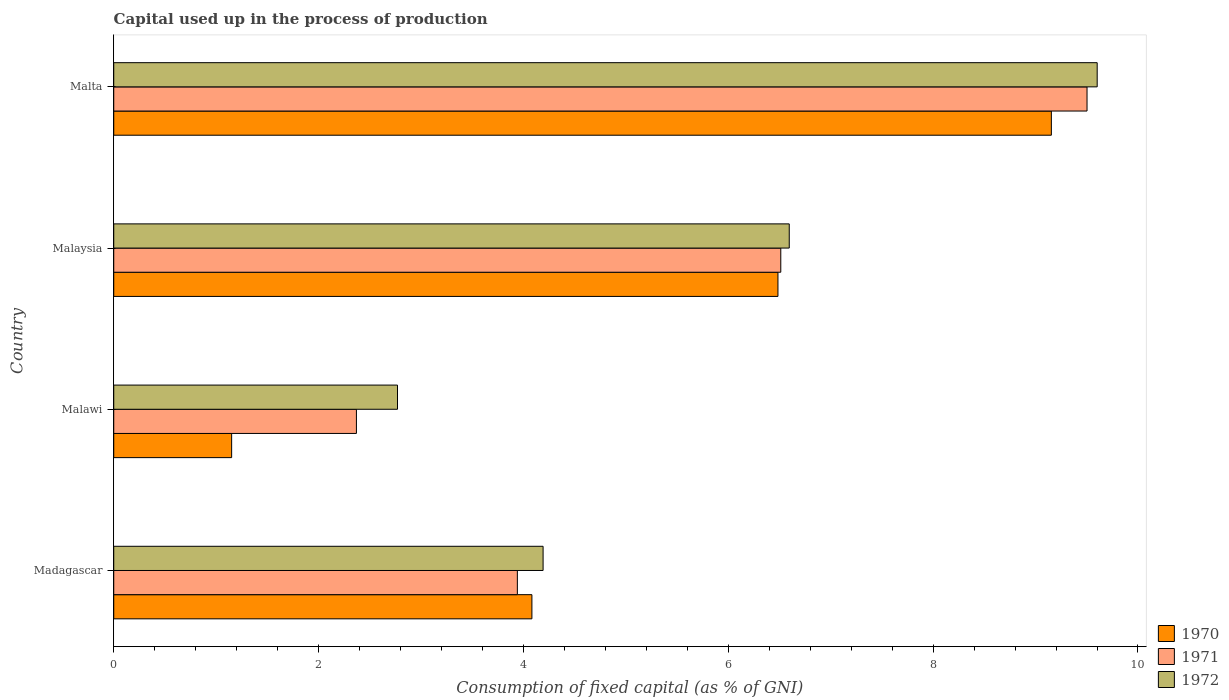How many groups of bars are there?
Give a very brief answer. 4. Are the number of bars per tick equal to the number of legend labels?
Keep it short and to the point. Yes. How many bars are there on the 1st tick from the bottom?
Your response must be concise. 3. What is the label of the 3rd group of bars from the top?
Your answer should be compact. Malawi. In how many cases, is the number of bars for a given country not equal to the number of legend labels?
Offer a very short reply. 0. What is the capital used up in the process of production in 1970 in Malaysia?
Your answer should be compact. 6.48. Across all countries, what is the maximum capital used up in the process of production in 1970?
Give a very brief answer. 9.15. Across all countries, what is the minimum capital used up in the process of production in 1972?
Offer a very short reply. 2.77. In which country was the capital used up in the process of production in 1971 maximum?
Make the answer very short. Malta. In which country was the capital used up in the process of production in 1970 minimum?
Offer a very short reply. Malawi. What is the total capital used up in the process of production in 1970 in the graph?
Your answer should be very brief. 20.87. What is the difference between the capital used up in the process of production in 1970 in Madagascar and that in Malaysia?
Ensure brevity in your answer.  -2.4. What is the difference between the capital used up in the process of production in 1972 in Malawi and the capital used up in the process of production in 1970 in Malta?
Offer a terse response. -6.38. What is the average capital used up in the process of production in 1971 per country?
Provide a succinct answer. 5.58. What is the difference between the capital used up in the process of production in 1971 and capital used up in the process of production in 1970 in Malaysia?
Provide a succinct answer. 0.03. In how many countries, is the capital used up in the process of production in 1970 greater than 2 %?
Keep it short and to the point. 3. What is the ratio of the capital used up in the process of production in 1971 in Malawi to that in Malta?
Give a very brief answer. 0.25. Is the difference between the capital used up in the process of production in 1971 in Madagascar and Malawi greater than the difference between the capital used up in the process of production in 1970 in Madagascar and Malawi?
Give a very brief answer. No. What is the difference between the highest and the second highest capital used up in the process of production in 1972?
Your answer should be very brief. 3.01. What is the difference between the highest and the lowest capital used up in the process of production in 1970?
Provide a succinct answer. 8. In how many countries, is the capital used up in the process of production in 1972 greater than the average capital used up in the process of production in 1972 taken over all countries?
Offer a terse response. 2. What does the 3rd bar from the bottom in Malaysia represents?
Offer a terse response. 1972. Is it the case that in every country, the sum of the capital used up in the process of production in 1971 and capital used up in the process of production in 1970 is greater than the capital used up in the process of production in 1972?
Provide a succinct answer. Yes. How many bars are there?
Offer a very short reply. 12. What is the difference between two consecutive major ticks on the X-axis?
Offer a very short reply. 2. Does the graph contain any zero values?
Offer a very short reply. No. Does the graph contain grids?
Ensure brevity in your answer.  No. What is the title of the graph?
Your response must be concise. Capital used up in the process of production. Does "1981" appear as one of the legend labels in the graph?
Make the answer very short. No. What is the label or title of the X-axis?
Your answer should be very brief. Consumption of fixed capital (as % of GNI). What is the label or title of the Y-axis?
Offer a very short reply. Country. What is the Consumption of fixed capital (as % of GNI) of 1970 in Madagascar?
Offer a very short reply. 4.08. What is the Consumption of fixed capital (as % of GNI) of 1971 in Madagascar?
Your answer should be compact. 3.94. What is the Consumption of fixed capital (as % of GNI) in 1972 in Madagascar?
Make the answer very short. 4.19. What is the Consumption of fixed capital (as % of GNI) of 1970 in Malawi?
Ensure brevity in your answer.  1.15. What is the Consumption of fixed capital (as % of GNI) of 1971 in Malawi?
Your answer should be very brief. 2.37. What is the Consumption of fixed capital (as % of GNI) in 1972 in Malawi?
Offer a very short reply. 2.77. What is the Consumption of fixed capital (as % of GNI) in 1970 in Malaysia?
Offer a very short reply. 6.48. What is the Consumption of fixed capital (as % of GNI) in 1971 in Malaysia?
Offer a very short reply. 6.51. What is the Consumption of fixed capital (as % of GNI) of 1972 in Malaysia?
Offer a terse response. 6.6. What is the Consumption of fixed capital (as % of GNI) of 1970 in Malta?
Provide a succinct answer. 9.15. What is the Consumption of fixed capital (as % of GNI) in 1971 in Malta?
Offer a very short reply. 9.5. What is the Consumption of fixed capital (as % of GNI) in 1972 in Malta?
Your answer should be compact. 9.6. Across all countries, what is the maximum Consumption of fixed capital (as % of GNI) in 1970?
Give a very brief answer. 9.15. Across all countries, what is the maximum Consumption of fixed capital (as % of GNI) of 1971?
Give a very brief answer. 9.5. Across all countries, what is the maximum Consumption of fixed capital (as % of GNI) in 1972?
Your response must be concise. 9.6. Across all countries, what is the minimum Consumption of fixed capital (as % of GNI) in 1970?
Provide a succinct answer. 1.15. Across all countries, what is the minimum Consumption of fixed capital (as % of GNI) of 1971?
Provide a short and direct response. 2.37. Across all countries, what is the minimum Consumption of fixed capital (as % of GNI) in 1972?
Your answer should be very brief. 2.77. What is the total Consumption of fixed capital (as % of GNI) in 1970 in the graph?
Provide a succinct answer. 20.87. What is the total Consumption of fixed capital (as % of GNI) in 1971 in the graph?
Provide a succinct answer. 22.32. What is the total Consumption of fixed capital (as % of GNI) in 1972 in the graph?
Your answer should be compact. 23.16. What is the difference between the Consumption of fixed capital (as % of GNI) of 1970 in Madagascar and that in Malawi?
Keep it short and to the point. 2.93. What is the difference between the Consumption of fixed capital (as % of GNI) of 1971 in Madagascar and that in Malawi?
Provide a short and direct response. 1.57. What is the difference between the Consumption of fixed capital (as % of GNI) in 1972 in Madagascar and that in Malawi?
Provide a succinct answer. 1.42. What is the difference between the Consumption of fixed capital (as % of GNI) in 1970 in Madagascar and that in Malaysia?
Offer a very short reply. -2.4. What is the difference between the Consumption of fixed capital (as % of GNI) of 1971 in Madagascar and that in Malaysia?
Provide a succinct answer. -2.57. What is the difference between the Consumption of fixed capital (as % of GNI) of 1972 in Madagascar and that in Malaysia?
Your answer should be very brief. -2.4. What is the difference between the Consumption of fixed capital (as % of GNI) of 1970 in Madagascar and that in Malta?
Provide a succinct answer. -5.07. What is the difference between the Consumption of fixed capital (as % of GNI) of 1971 in Madagascar and that in Malta?
Make the answer very short. -5.56. What is the difference between the Consumption of fixed capital (as % of GNI) in 1972 in Madagascar and that in Malta?
Ensure brevity in your answer.  -5.41. What is the difference between the Consumption of fixed capital (as % of GNI) of 1970 in Malawi and that in Malaysia?
Your response must be concise. -5.33. What is the difference between the Consumption of fixed capital (as % of GNI) in 1971 in Malawi and that in Malaysia?
Give a very brief answer. -4.14. What is the difference between the Consumption of fixed capital (as % of GNI) of 1972 in Malawi and that in Malaysia?
Provide a succinct answer. -3.82. What is the difference between the Consumption of fixed capital (as % of GNI) in 1970 in Malawi and that in Malta?
Your answer should be compact. -8. What is the difference between the Consumption of fixed capital (as % of GNI) in 1971 in Malawi and that in Malta?
Your answer should be very brief. -7.13. What is the difference between the Consumption of fixed capital (as % of GNI) of 1972 in Malawi and that in Malta?
Your response must be concise. -6.83. What is the difference between the Consumption of fixed capital (as % of GNI) in 1970 in Malaysia and that in Malta?
Your response must be concise. -2.67. What is the difference between the Consumption of fixed capital (as % of GNI) in 1971 in Malaysia and that in Malta?
Your answer should be very brief. -2.99. What is the difference between the Consumption of fixed capital (as % of GNI) of 1972 in Malaysia and that in Malta?
Offer a terse response. -3.01. What is the difference between the Consumption of fixed capital (as % of GNI) of 1970 in Madagascar and the Consumption of fixed capital (as % of GNI) of 1971 in Malawi?
Keep it short and to the point. 1.71. What is the difference between the Consumption of fixed capital (as % of GNI) in 1970 in Madagascar and the Consumption of fixed capital (as % of GNI) in 1972 in Malawi?
Your answer should be compact. 1.31. What is the difference between the Consumption of fixed capital (as % of GNI) in 1971 in Madagascar and the Consumption of fixed capital (as % of GNI) in 1972 in Malawi?
Your response must be concise. 1.17. What is the difference between the Consumption of fixed capital (as % of GNI) in 1970 in Madagascar and the Consumption of fixed capital (as % of GNI) in 1971 in Malaysia?
Provide a short and direct response. -2.43. What is the difference between the Consumption of fixed capital (as % of GNI) of 1970 in Madagascar and the Consumption of fixed capital (as % of GNI) of 1972 in Malaysia?
Your answer should be very brief. -2.51. What is the difference between the Consumption of fixed capital (as % of GNI) in 1971 in Madagascar and the Consumption of fixed capital (as % of GNI) in 1972 in Malaysia?
Offer a terse response. -2.65. What is the difference between the Consumption of fixed capital (as % of GNI) of 1970 in Madagascar and the Consumption of fixed capital (as % of GNI) of 1971 in Malta?
Offer a very short reply. -5.42. What is the difference between the Consumption of fixed capital (as % of GNI) in 1970 in Madagascar and the Consumption of fixed capital (as % of GNI) in 1972 in Malta?
Give a very brief answer. -5.52. What is the difference between the Consumption of fixed capital (as % of GNI) of 1971 in Madagascar and the Consumption of fixed capital (as % of GNI) of 1972 in Malta?
Give a very brief answer. -5.66. What is the difference between the Consumption of fixed capital (as % of GNI) in 1970 in Malawi and the Consumption of fixed capital (as % of GNI) in 1971 in Malaysia?
Offer a very short reply. -5.36. What is the difference between the Consumption of fixed capital (as % of GNI) of 1970 in Malawi and the Consumption of fixed capital (as % of GNI) of 1972 in Malaysia?
Your answer should be compact. -5.44. What is the difference between the Consumption of fixed capital (as % of GNI) of 1971 in Malawi and the Consumption of fixed capital (as % of GNI) of 1972 in Malaysia?
Your response must be concise. -4.23. What is the difference between the Consumption of fixed capital (as % of GNI) of 1970 in Malawi and the Consumption of fixed capital (as % of GNI) of 1971 in Malta?
Make the answer very short. -8.35. What is the difference between the Consumption of fixed capital (as % of GNI) in 1970 in Malawi and the Consumption of fixed capital (as % of GNI) in 1972 in Malta?
Give a very brief answer. -8.45. What is the difference between the Consumption of fixed capital (as % of GNI) of 1971 in Malawi and the Consumption of fixed capital (as % of GNI) of 1972 in Malta?
Keep it short and to the point. -7.23. What is the difference between the Consumption of fixed capital (as % of GNI) in 1970 in Malaysia and the Consumption of fixed capital (as % of GNI) in 1971 in Malta?
Your answer should be very brief. -3.02. What is the difference between the Consumption of fixed capital (as % of GNI) in 1970 in Malaysia and the Consumption of fixed capital (as % of GNI) in 1972 in Malta?
Give a very brief answer. -3.12. What is the difference between the Consumption of fixed capital (as % of GNI) in 1971 in Malaysia and the Consumption of fixed capital (as % of GNI) in 1972 in Malta?
Give a very brief answer. -3.09. What is the average Consumption of fixed capital (as % of GNI) of 1970 per country?
Your answer should be compact. 5.22. What is the average Consumption of fixed capital (as % of GNI) in 1971 per country?
Provide a short and direct response. 5.58. What is the average Consumption of fixed capital (as % of GNI) in 1972 per country?
Keep it short and to the point. 5.79. What is the difference between the Consumption of fixed capital (as % of GNI) in 1970 and Consumption of fixed capital (as % of GNI) in 1971 in Madagascar?
Offer a very short reply. 0.14. What is the difference between the Consumption of fixed capital (as % of GNI) in 1970 and Consumption of fixed capital (as % of GNI) in 1972 in Madagascar?
Your response must be concise. -0.11. What is the difference between the Consumption of fixed capital (as % of GNI) in 1971 and Consumption of fixed capital (as % of GNI) in 1972 in Madagascar?
Your answer should be very brief. -0.25. What is the difference between the Consumption of fixed capital (as % of GNI) in 1970 and Consumption of fixed capital (as % of GNI) in 1971 in Malawi?
Offer a very short reply. -1.22. What is the difference between the Consumption of fixed capital (as % of GNI) of 1970 and Consumption of fixed capital (as % of GNI) of 1972 in Malawi?
Provide a succinct answer. -1.62. What is the difference between the Consumption of fixed capital (as % of GNI) in 1971 and Consumption of fixed capital (as % of GNI) in 1972 in Malawi?
Provide a short and direct response. -0.4. What is the difference between the Consumption of fixed capital (as % of GNI) in 1970 and Consumption of fixed capital (as % of GNI) in 1971 in Malaysia?
Give a very brief answer. -0.03. What is the difference between the Consumption of fixed capital (as % of GNI) in 1970 and Consumption of fixed capital (as % of GNI) in 1972 in Malaysia?
Your response must be concise. -0.11. What is the difference between the Consumption of fixed capital (as % of GNI) of 1971 and Consumption of fixed capital (as % of GNI) of 1972 in Malaysia?
Provide a short and direct response. -0.08. What is the difference between the Consumption of fixed capital (as % of GNI) of 1970 and Consumption of fixed capital (as % of GNI) of 1971 in Malta?
Make the answer very short. -0.35. What is the difference between the Consumption of fixed capital (as % of GNI) of 1970 and Consumption of fixed capital (as % of GNI) of 1972 in Malta?
Provide a short and direct response. -0.45. What is the difference between the Consumption of fixed capital (as % of GNI) in 1971 and Consumption of fixed capital (as % of GNI) in 1972 in Malta?
Provide a short and direct response. -0.1. What is the ratio of the Consumption of fixed capital (as % of GNI) in 1970 in Madagascar to that in Malawi?
Your response must be concise. 3.55. What is the ratio of the Consumption of fixed capital (as % of GNI) of 1971 in Madagascar to that in Malawi?
Offer a terse response. 1.66. What is the ratio of the Consumption of fixed capital (as % of GNI) in 1972 in Madagascar to that in Malawi?
Offer a very short reply. 1.51. What is the ratio of the Consumption of fixed capital (as % of GNI) in 1970 in Madagascar to that in Malaysia?
Ensure brevity in your answer.  0.63. What is the ratio of the Consumption of fixed capital (as % of GNI) of 1971 in Madagascar to that in Malaysia?
Make the answer very short. 0.61. What is the ratio of the Consumption of fixed capital (as % of GNI) of 1972 in Madagascar to that in Malaysia?
Make the answer very short. 0.64. What is the ratio of the Consumption of fixed capital (as % of GNI) of 1970 in Madagascar to that in Malta?
Provide a succinct answer. 0.45. What is the ratio of the Consumption of fixed capital (as % of GNI) in 1971 in Madagascar to that in Malta?
Offer a terse response. 0.41. What is the ratio of the Consumption of fixed capital (as % of GNI) in 1972 in Madagascar to that in Malta?
Your answer should be compact. 0.44. What is the ratio of the Consumption of fixed capital (as % of GNI) of 1970 in Malawi to that in Malaysia?
Provide a short and direct response. 0.18. What is the ratio of the Consumption of fixed capital (as % of GNI) in 1971 in Malawi to that in Malaysia?
Your answer should be compact. 0.36. What is the ratio of the Consumption of fixed capital (as % of GNI) in 1972 in Malawi to that in Malaysia?
Provide a short and direct response. 0.42. What is the ratio of the Consumption of fixed capital (as % of GNI) of 1970 in Malawi to that in Malta?
Give a very brief answer. 0.13. What is the ratio of the Consumption of fixed capital (as % of GNI) of 1971 in Malawi to that in Malta?
Give a very brief answer. 0.25. What is the ratio of the Consumption of fixed capital (as % of GNI) in 1972 in Malawi to that in Malta?
Keep it short and to the point. 0.29. What is the ratio of the Consumption of fixed capital (as % of GNI) in 1970 in Malaysia to that in Malta?
Provide a short and direct response. 0.71. What is the ratio of the Consumption of fixed capital (as % of GNI) in 1971 in Malaysia to that in Malta?
Your answer should be very brief. 0.69. What is the ratio of the Consumption of fixed capital (as % of GNI) of 1972 in Malaysia to that in Malta?
Keep it short and to the point. 0.69. What is the difference between the highest and the second highest Consumption of fixed capital (as % of GNI) in 1970?
Give a very brief answer. 2.67. What is the difference between the highest and the second highest Consumption of fixed capital (as % of GNI) in 1971?
Offer a very short reply. 2.99. What is the difference between the highest and the second highest Consumption of fixed capital (as % of GNI) of 1972?
Ensure brevity in your answer.  3.01. What is the difference between the highest and the lowest Consumption of fixed capital (as % of GNI) in 1970?
Provide a succinct answer. 8. What is the difference between the highest and the lowest Consumption of fixed capital (as % of GNI) of 1971?
Give a very brief answer. 7.13. What is the difference between the highest and the lowest Consumption of fixed capital (as % of GNI) of 1972?
Give a very brief answer. 6.83. 